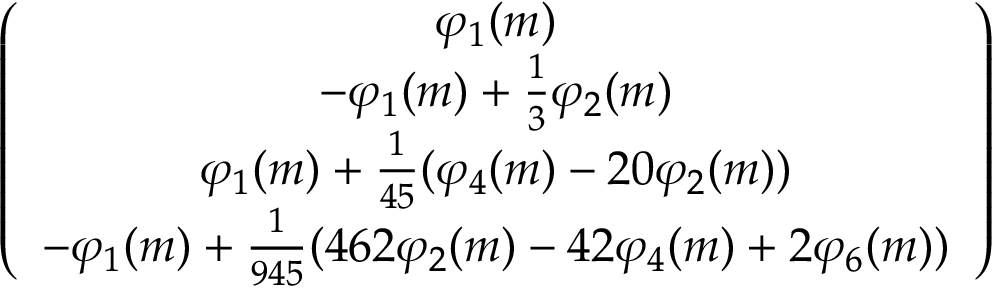<formula> <loc_0><loc_0><loc_500><loc_500>\begin{array} { r } { \left ( \begin{array} { c } { \varphi _ { 1 } ( m ) } \\ { - \varphi _ { 1 } ( m ) + \frac { 1 } { 3 } \varphi _ { 2 } ( m ) } \\ { \varphi _ { 1 } ( m ) + \frac { 1 } { 4 5 } ( \varphi _ { 4 } ( m ) - 2 0 \varphi _ { 2 } ( m ) ) } \\ { - \varphi _ { 1 } ( m ) + \frac { 1 } { 9 4 5 } ( 4 6 2 \varphi _ { 2 } ( m ) - 4 2 \varphi _ { 4 } ( m ) + 2 \varphi _ { 6 } ( m ) ) } \end{array} \right ) } \end{array}</formula> 